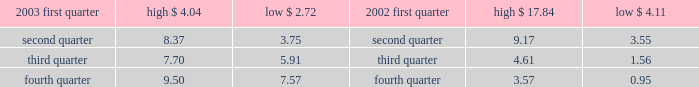Part ii item 5 .
Market for registrant 2019s common equity and related stockholder matters recent sales of unregistered securities during the fourth quarter of 2003 , aes issued an aggregated of 20.2 million shares of its common stock in exchange for $ 20 million aggregate principal amount of its senior notes .
The shares were issued without registration in reliance upon section 3 ( a ) ( 9 ) under the securities act of 1933 .
Market information our common stock is currently traded on the new york stock exchange ( 2018 2018nyse 2019 2019 ) under the symbol 2018 2018aes . 2019 2019 the tables set forth the high and low sale prices for our common stock as reported by the nyse for the periods indicated .
Price range of common stock .
Holders as of march 3 , 2004 , there were 9026 record holders of our common stock , par value $ 0.01 per share .
Dividends under the terms of our senior secured credit facilities , which we entered into with a commercial bank syndicate , we are not allowed to pay cash dividends .
In addition , under the terms of a guaranty we provided to the utility customer in connection with the aes thames project , we are precluded from paying cash dividends on our common stock if we do not meet certain net worth and liquidity tests .
Our project subsidiaries 2019 ability to declare and pay cash dividends to us is subject to certain limitations contained in the project loans , governmental provisions and other agreements that our project subsidiaries are subject to .
See item 12 ( d ) of this form 10-k for information regarding securities authorized for issuance under equity compensation plans. .
What was the difference in the low price for the first quarter of 2003 and the high price for the fourth quarter of 2003? 
Computations: (9.50 - 2.72)
Answer: 6.78. 